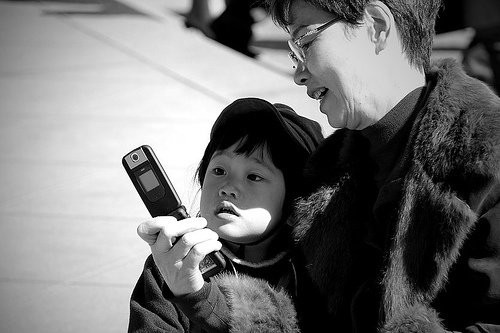Describe the objects in this image and their specific colors. I can see people in black, gray, lightgray, and darkgray tones, people in black, gray, white, and darkgray tones, and cell phone in black, gray, darkgray, and lightgray tones in this image. 